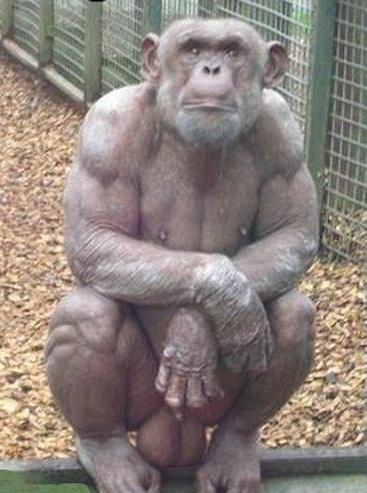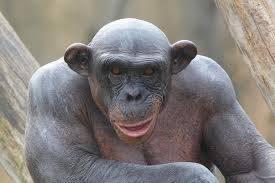The first image is the image on the left, the second image is the image on the right. Examine the images to the left and right. Is the description "The animal in the image on the left has both arms resting on its knees." accurate? Answer yes or no. Yes. 